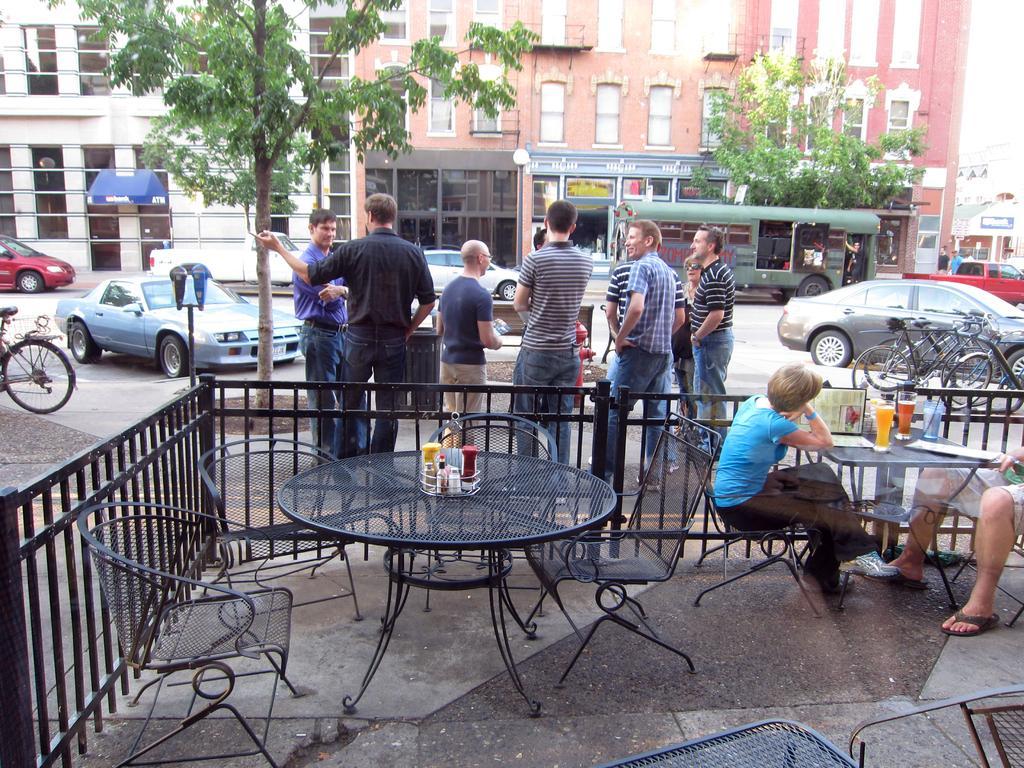Describe this image in one or two sentences. A couple are sitting at a table in a restaurant. There are some men standing beside the restaurant. There are some cars and vehicles passing on the road. There is a building and trees in the background. 